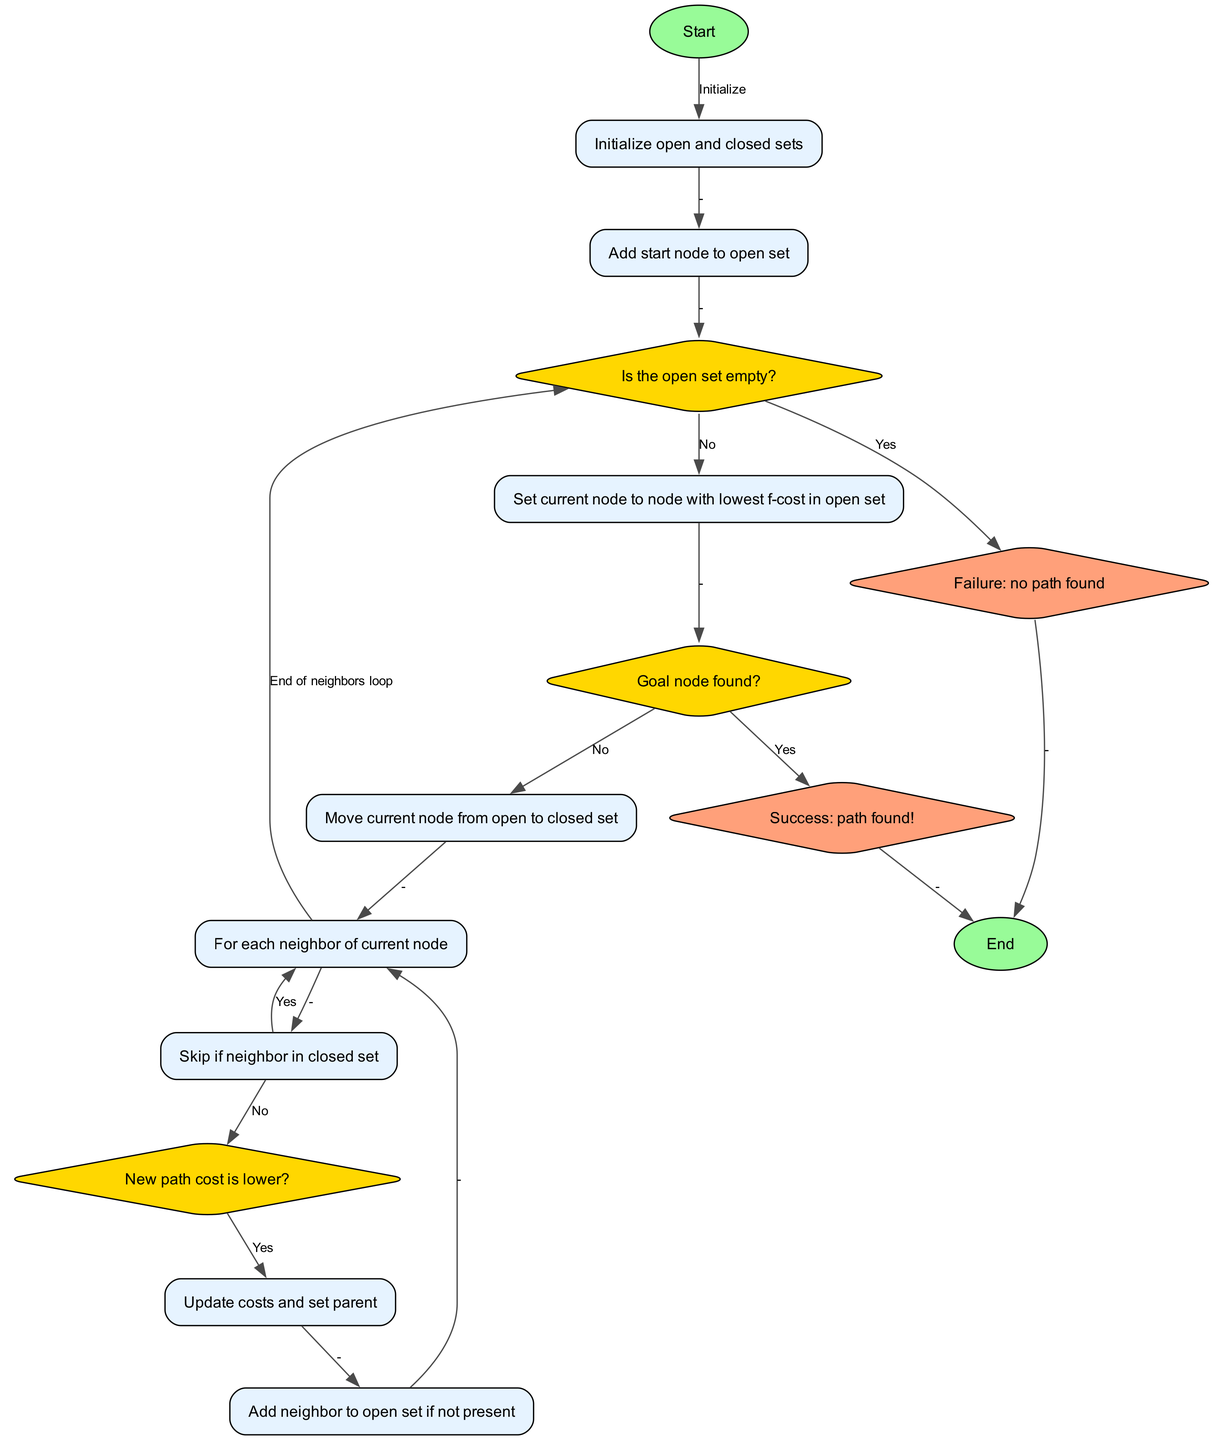What is the starting point of the algorithm? The diagram begins with the "Start" node, which indicates the initial step of the algorithm.
Answer: Start How many nodes are represented in the diagram? Counting all unique nodes listed in the diagram provides a total of 15 nodes indicating parts of the A* pathfinding process.
Answer: 15 What should be done if the open set is empty? According to the flowchart, if the open set is empty, the process leads to the "Failure: no path found" node, indicating the absence of a viable path.
Answer: Failure: no path found What action occurs after moving the current node to the closed set? After moving the current node from the open set to the closed set, the next step is to look at the "neighbors" of the current node to continue the pathfinding process.
Answer: For each neighbor of current node How does the algorithm determine if a path to the goal has been found? The algorithm checks the "Goal node found?" decision node to determine if the end goal has been reached based on the current node's status.
Answer: Goal node found? If a neighbor is already in the closed set, what will the algorithm do? The algorithm will skip the neighbor if it is found in the closed set, as indicated by the "Skip if neighbor in closed set" node in the flowchart.
Answer: Skip Which node represents a successful pathfinding outcome? The "Success: path found!" node represents the outcome where the algorithm has successfully found a path from the start to the goal node.
Answer: Success: path found! What happens to a neighbor if the new path cost is lower? If the new path cost is lower, the algorithm updates the costs and sets the parent, proceeding with adjustments necessary for optimal pathfinding.
Answer: Update costs and set parent What kind of node is used to indicate a decision point in the diagram? Decision points in the diagram are represented as diamond-shaped nodes, known for indicating branches based on yes/no outcomes during the pathfinding process.
Answer: Diamond-shaped nodes 